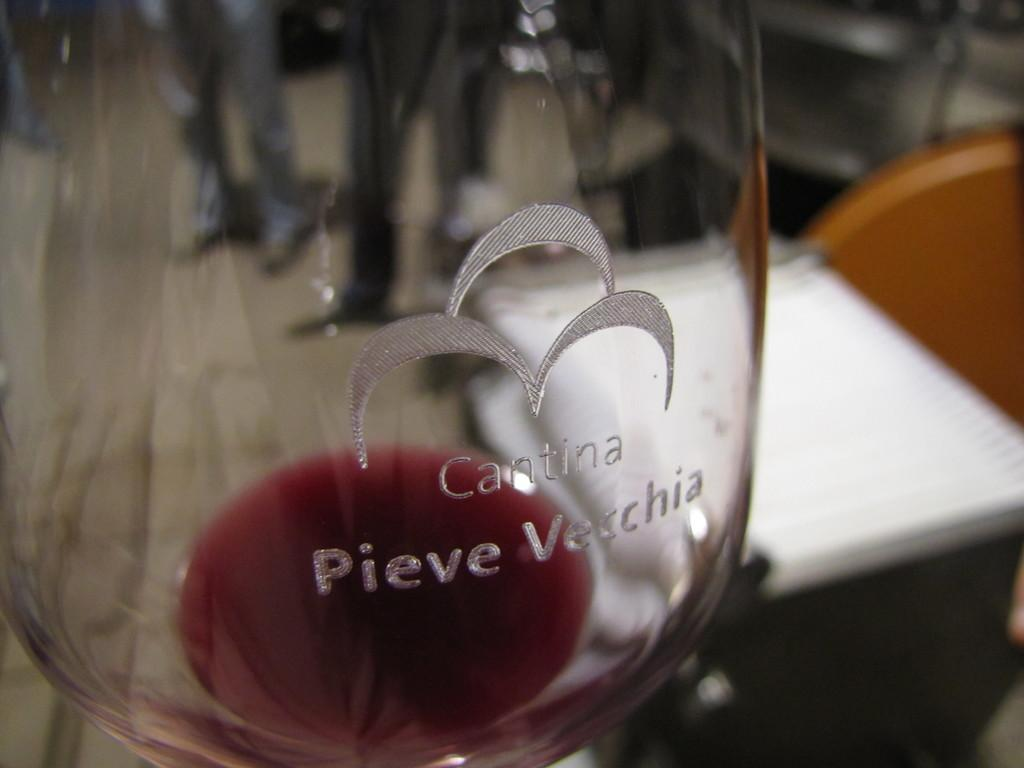<image>
Write a terse but informative summary of the picture. A wine glass engraved with Cantina Pieve Vecchia on it. 